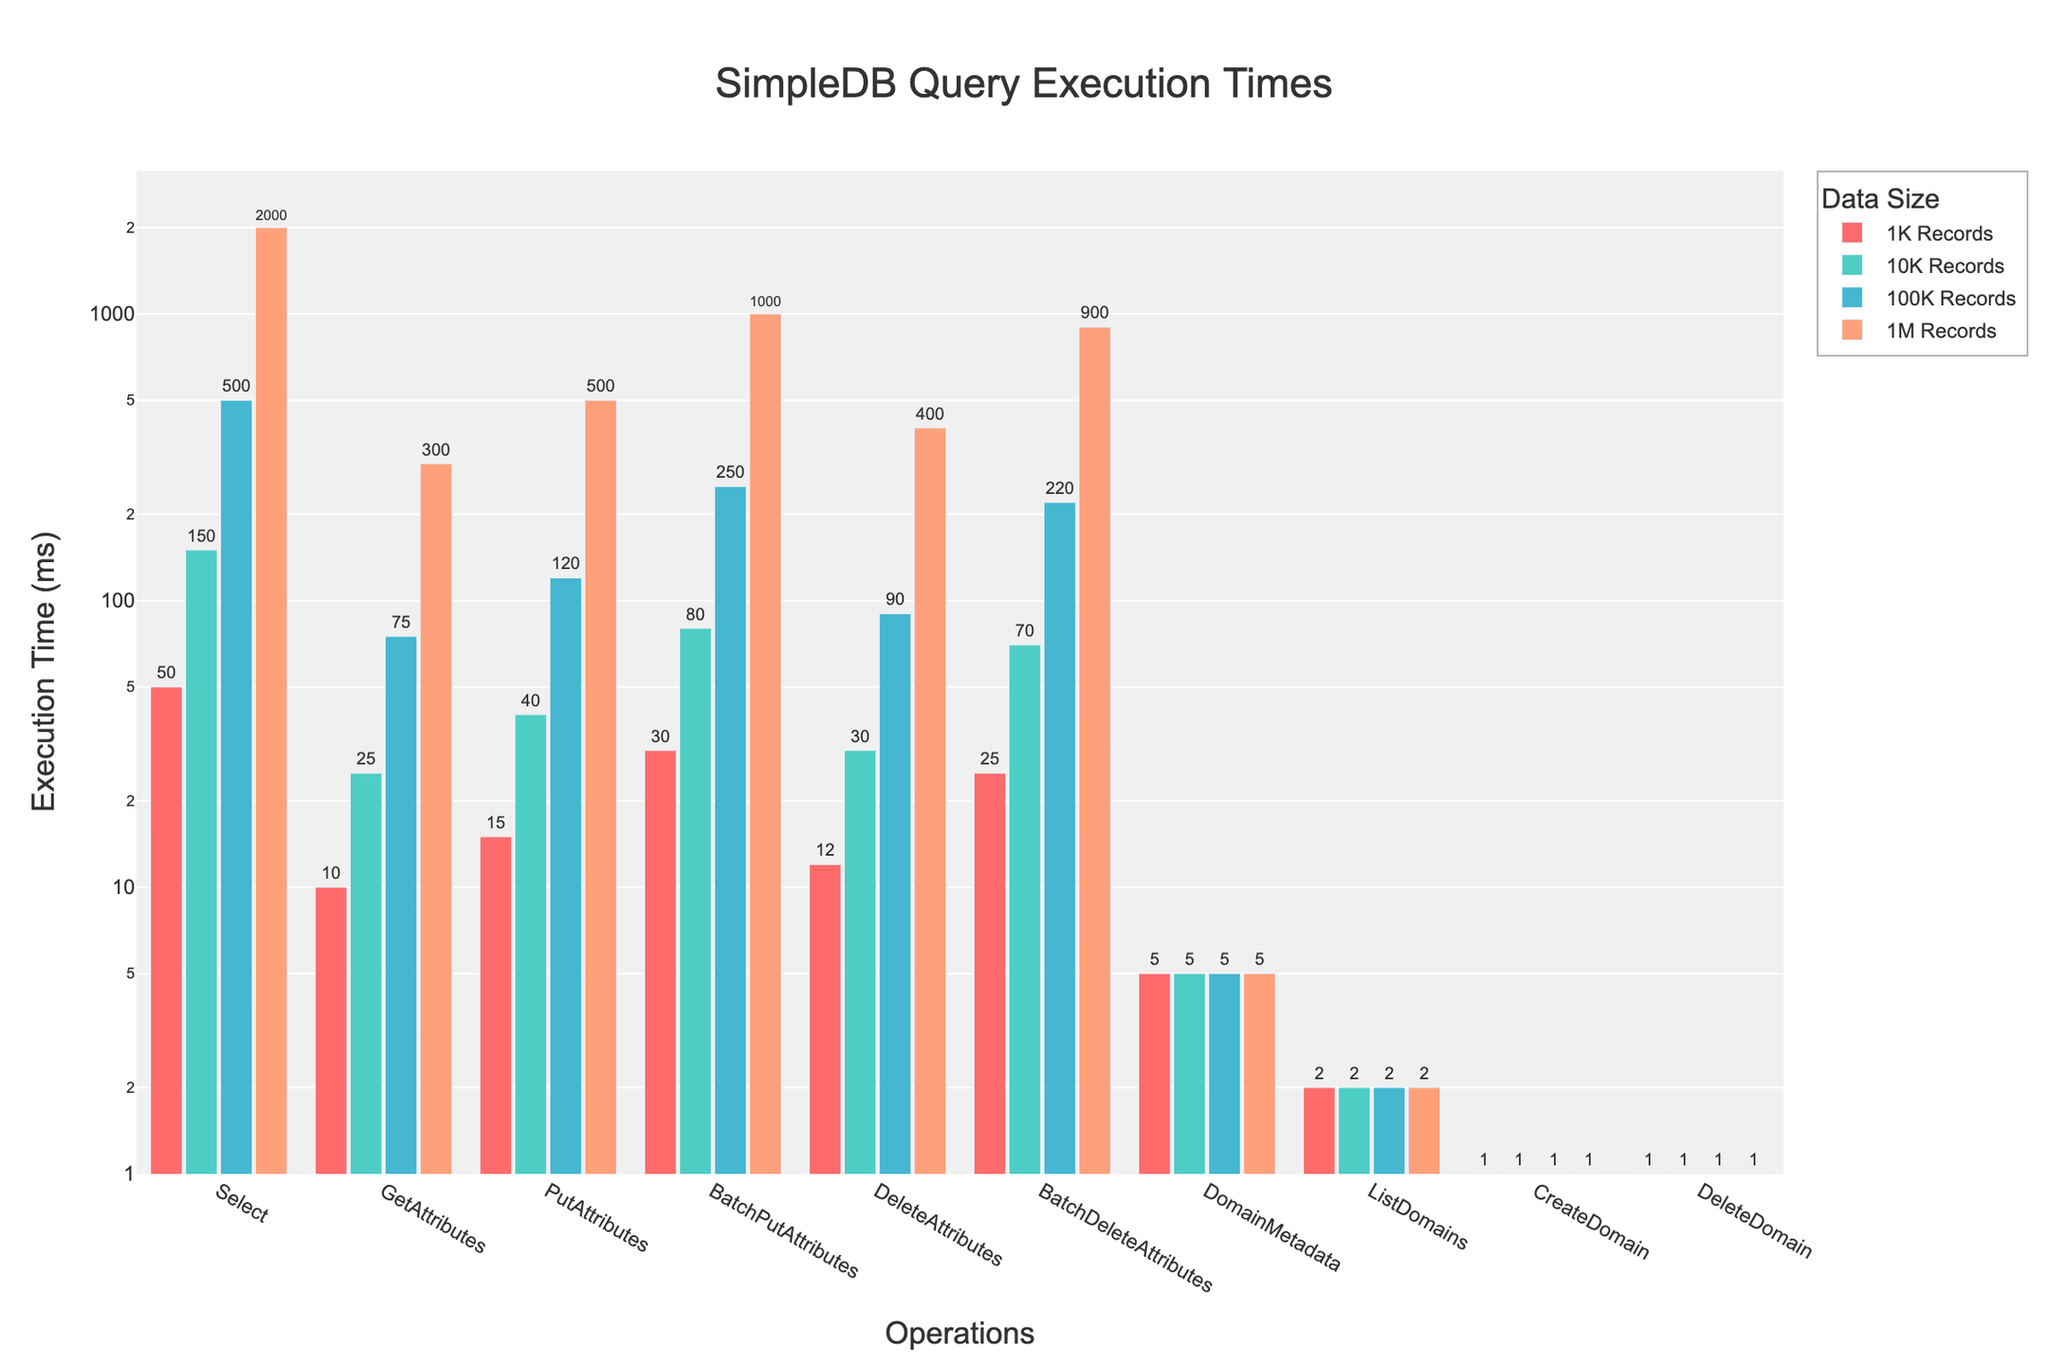What operation has the longest execution time for 1 million records? By examining the figure, it is clear that the "Select" operation has the tallest bar for the data size of 1 million records, indicating the longest execution time.
Answer: Select Which operation has consistent execution times across all data sizes? The bars for the "ListDomains" and "CreateDomain" operations remain the same height across all data sizes, indicating consistent execution times.
Answer: ListDomains and CreateDomain What is the difference in execution time between "BatchPutAttributes" and "DeleteAttributes" for 100K records? For 100K records, the execution time of "BatchPutAttributes" is 250 ms and for "DeleteAttributes" it is 90 ms. The difference is 250 - 90 = 160 ms.
Answer: 160 ms What is the average execution time of "GetAttributes" operation across all data sizes? The execution times for "GetAttributes" operation are 10, 25, 75, and 300 ms for 1K, 10K, 100K, and 1M records respectively. The average is calculated as (10 + 25 + 75 + 300) / 4 = 102.5 ms.
Answer: 102.5 ms Compare the execution times between "PutAttributes" and "DeleteAttributes" for 10K records. Which one is faster and by how much? For 10K records, "PutAttributes" takes 40 ms, while "DeleteAttributes" takes 30 ms. "DeleteAttributes" is faster by 40 - 30 = 10 ms.
Answer: DeleteAttributes by 10 ms Which operation's execution time increases the most from 1K to 1M records? By observing the figure, the "Select" operation shows the most significant increase in execution time from 50 ms (1K records) to 2000 ms (1M records), an increase of 2000 - 50 = 1950 ms.
Answer: Select What is the total execution time for the "BatchDeleteAttributes" operation across all data sizes? The execution times for "BatchDeleteAttributes" are 25, 70, 220, and 900 ms for 1K, 10K, 100K, and 1M records respectively. The total time is 25 + 70 + 220 + 900 = 1215 ms.
Answer: 1215 ms How much longer does the "BatchPutAttributes" operation for 1M records take compared to "Select" operation for 100K records? The "BatchPutAttributes" operation for 1M records takes 1000 ms, whereas the "Select" operation for 100K records takes 500 ms. The difference is 1000 - 500 = 500 ms.
Answer: 500 ms Which operation has the smallest execution time and what is it? The "CreateDomain" and "DeleteDomain" operations have the smallest execution time of 1 ms across all data sizes.
Answer: CreateDomain and DeleteDomain with 1 ms Does the "DomainMetadata" operation's execution time change with data size? By examining the bars for the "DomainMetadata" operation, we can see they remain the same height across all data sizes, indicating no change in execution time.
Answer: No 